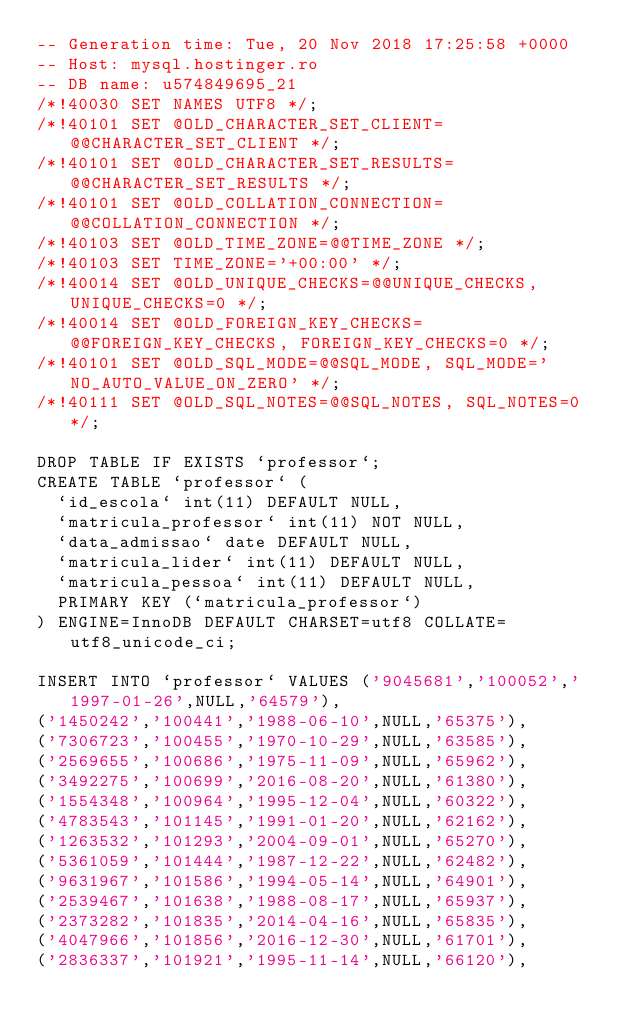<code> <loc_0><loc_0><loc_500><loc_500><_SQL_>-- Generation time: Tue, 20 Nov 2018 17:25:58 +0000
-- Host: mysql.hostinger.ro
-- DB name: u574849695_21
/*!40030 SET NAMES UTF8 */;
/*!40101 SET @OLD_CHARACTER_SET_CLIENT=@@CHARACTER_SET_CLIENT */;
/*!40101 SET @OLD_CHARACTER_SET_RESULTS=@@CHARACTER_SET_RESULTS */;
/*!40101 SET @OLD_COLLATION_CONNECTION=@@COLLATION_CONNECTION */;
/*!40103 SET @OLD_TIME_ZONE=@@TIME_ZONE */;
/*!40103 SET TIME_ZONE='+00:00' */;
/*!40014 SET @OLD_UNIQUE_CHECKS=@@UNIQUE_CHECKS, UNIQUE_CHECKS=0 */;
/*!40014 SET @OLD_FOREIGN_KEY_CHECKS=@@FOREIGN_KEY_CHECKS, FOREIGN_KEY_CHECKS=0 */;
/*!40101 SET @OLD_SQL_MODE=@@SQL_MODE, SQL_MODE='NO_AUTO_VALUE_ON_ZERO' */;
/*!40111 SET @OLD_SQL_NOTES=@@SQL_NOTES, SQL_NOTES=0 */;

DROP TABLE IF EXISTS `professor`;
CREATE TABLE `professor` (
  `id_escola` int(11) DEFAULT NULL,
  `matricula_professor` int(11) NOT NULL,
  `data_admissao` date DEFAULT NULL,
  `matricula_lider` int(11) DEFAULT NULL,
  `matricula_pessoa` int(11) DEFAULT NULL,
  PRIMARY KEY (`matricula_professor`)
) ENGINE=InnoDB DEFAULT CHARSET=utf8 COLLATE=utf8_unicode_ci;

INSERT INTO `professor` VALUES ('9045681','100052','1997-01-26',NULL,'64579'),
('1450242','100441','1988-06-10',NULL,'65375'),
('7306723','100455','1970-10-29',NULL,'63585'),
('2569655','100686','1975-11-09',NULL,'65962'),
('3492275','100699','2016-08-20',NULL,'61380'),
('1554348','100964','1995-12-04',NULL,'60322'),
('4783543','101145','1991-01-20',NULL,'62162'),
('1263532','101293','2004-09-01',NULL,'65270'),
('5361059','101444','1987-12-22',NULL,'62482'),
('9631967','101586','1994-05-14',NULL,'64901'),
('2539467','101638','1988-08-17',NULL,'65937'),
('2373282','101835','2014-04-16',NULL,'65835'),
('4047966','101856','2016-12-30',NULL,'61701'),
('2836337','101921','1995-11-14',NULL,'66120'),</code> 